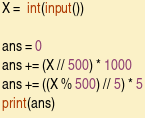Convert code to text. <code><loc_0><loc_0><loc_500><loc_500><_Python_>X =  int(input())

ans = 0
ans += (X // 500) * 1000
ans += ((X % 500) // 5) * 5
print(ans)</code> 